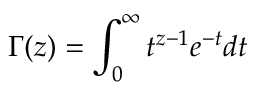Convert formula to latex. <formula><loc_0><loc_0><loc_500><loc_500>\Gamma ( z ) = \int _ { 0 } ^ { \infty } t ^ { z - 1 } e ^ { - t } d t</formula> 